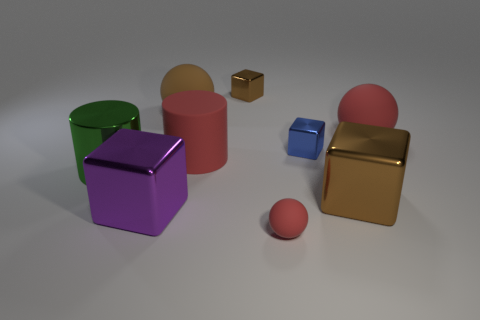There is a big cylinder behind the green cylinder; is there a large rubber thing that is left of it?
Offer a very short reply. Yes. Is the shape of the small blue thing the same as the large brown object that is in front of the large green cylinder?
Your response must be concise. Yes. There is a matte object that is on the right side of the big brown shiny block; what is its color?
Give a very brief answer. Red. What size is the brown shiny block that is behind the rubber sphere that is right of the tiny rubber object?
Ensure brevity in your answer.  Small. There is a large object that is in front of the big brown block; does it have the same shape as the small red thing?
Provide a succinct answer. No. There is a brown object that is the same shape as the small red thing; what material is it?
Give a very brief answer. Rubber. How many things are either large objects on the left side of the big red matte ball or brown metal blocks on the right side of the small brown shiny cube?
Make the answer very short. 5. Does the matte cylinder have the same color as the rubber ball that is in front of the big green cylinder?
Provide a short and direct response. Yes. There is a large brown object that is the same material as the small blue object; what shape is it?
Your answer should be very brief. Cube. How many shiny cylinders are there?
Offer a very short reply. 1. 